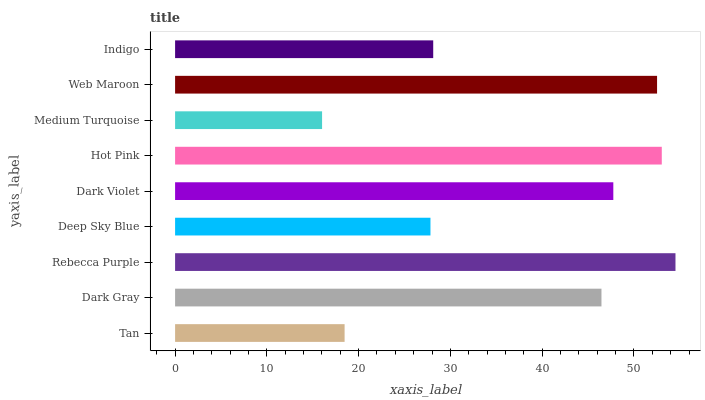Is Medium Turquoise the minimum?
Answer yes or no. Yes. Is Rebecca Purple the maximum?
Answer yes or no. Yes. Is Dark Gray the minimum?
Answer yes or no. No. Is Dark Gray the maximum?
Answer yes or no. No. Is Dark Gray greater than Tan?
Answer yes or no. Yes. Is Tan less than Dark Gray?
Answer yes or no. Yes. Is Tan greater than Dark Gray?
Answer yes or no. No. Is Dark Gray less than Tan?
Answer yes or no. No. Is Dark Gray the high median?
Answer yes or no. Yes. Is Dark Gray the low median?
Answer yes or no. Yes. Is Hot Pink the high median?
Answer yes or no. No. Is Tan the low median?
Answer yes or no. No. 